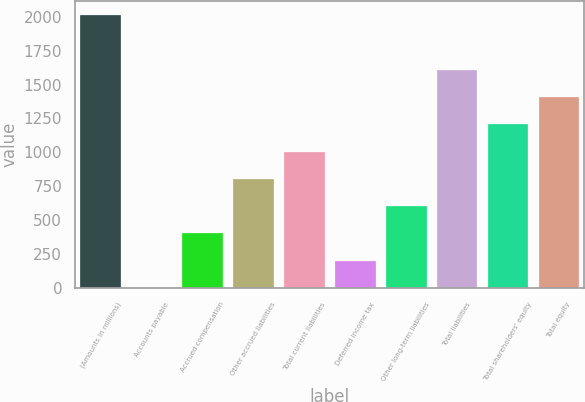<chart> <loc_0><loc_0><loc_500><loc_500><bar_chart><fcel>(Amounts in millions)<fcel>Accounts payable<fcel>Accrued compensation<fcel>Other accrued liabilities<fcel>Total current liabilities<fcel>Deferred income tax<fcel>Other long-term liabilities<fcel>Total liabilities<fcel>Total shareholders' equity<fcel>Total equity<nl><fcel>2012<fcel>0.4<fcel>402.72<fcel>805.04<fcel>1006.2<fcel>201.56<fcel>603.88<fcel>1609.68<fcel>1207.36<fcel>1408.52<nl></chart> 